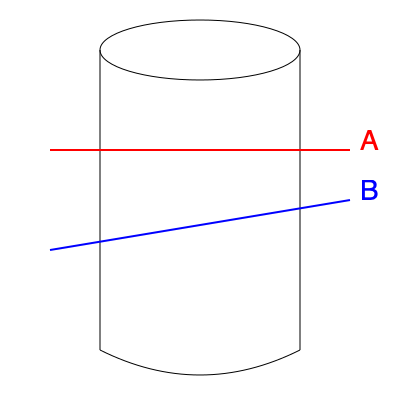As you're finishing your late shift at the Langham factory, you notice a cylindrical storage tank. If the tank were to be cut along planes A (horizontal) and B (angled), which cross-section shape would you see for each cut? To determine the cross-section shapes, we need to consider how the cutting planes intersect the cylindrical tank:

1. Plane A (horizontal, red line):
   - This plane is parallel to the circular base of the cylinder.
   - When a cylinder is cut parallel to its base, the resulting cross-section is always a circle.
   - The size of this circle would be equal to the diameter of the cylinder at that height.

2. Plane B (angled, blue line):
   - This plane intersects the cylinder at an angle that is not perpendicular to the cylinder's axis.
   - When a cylinder is cut at an angle that is not perpendicular to its axis, the resulting cross-section is an ellipse.
   - The eccentricity of the ellipse depends on the angle of the cut: the more angled the cut, the more elongated the ellipse.

In both cases, the cross-sections are conic sections, which are the result of a plane intersecting a cone or cylinder.
Answer: A: Circle, B: Ellipse 